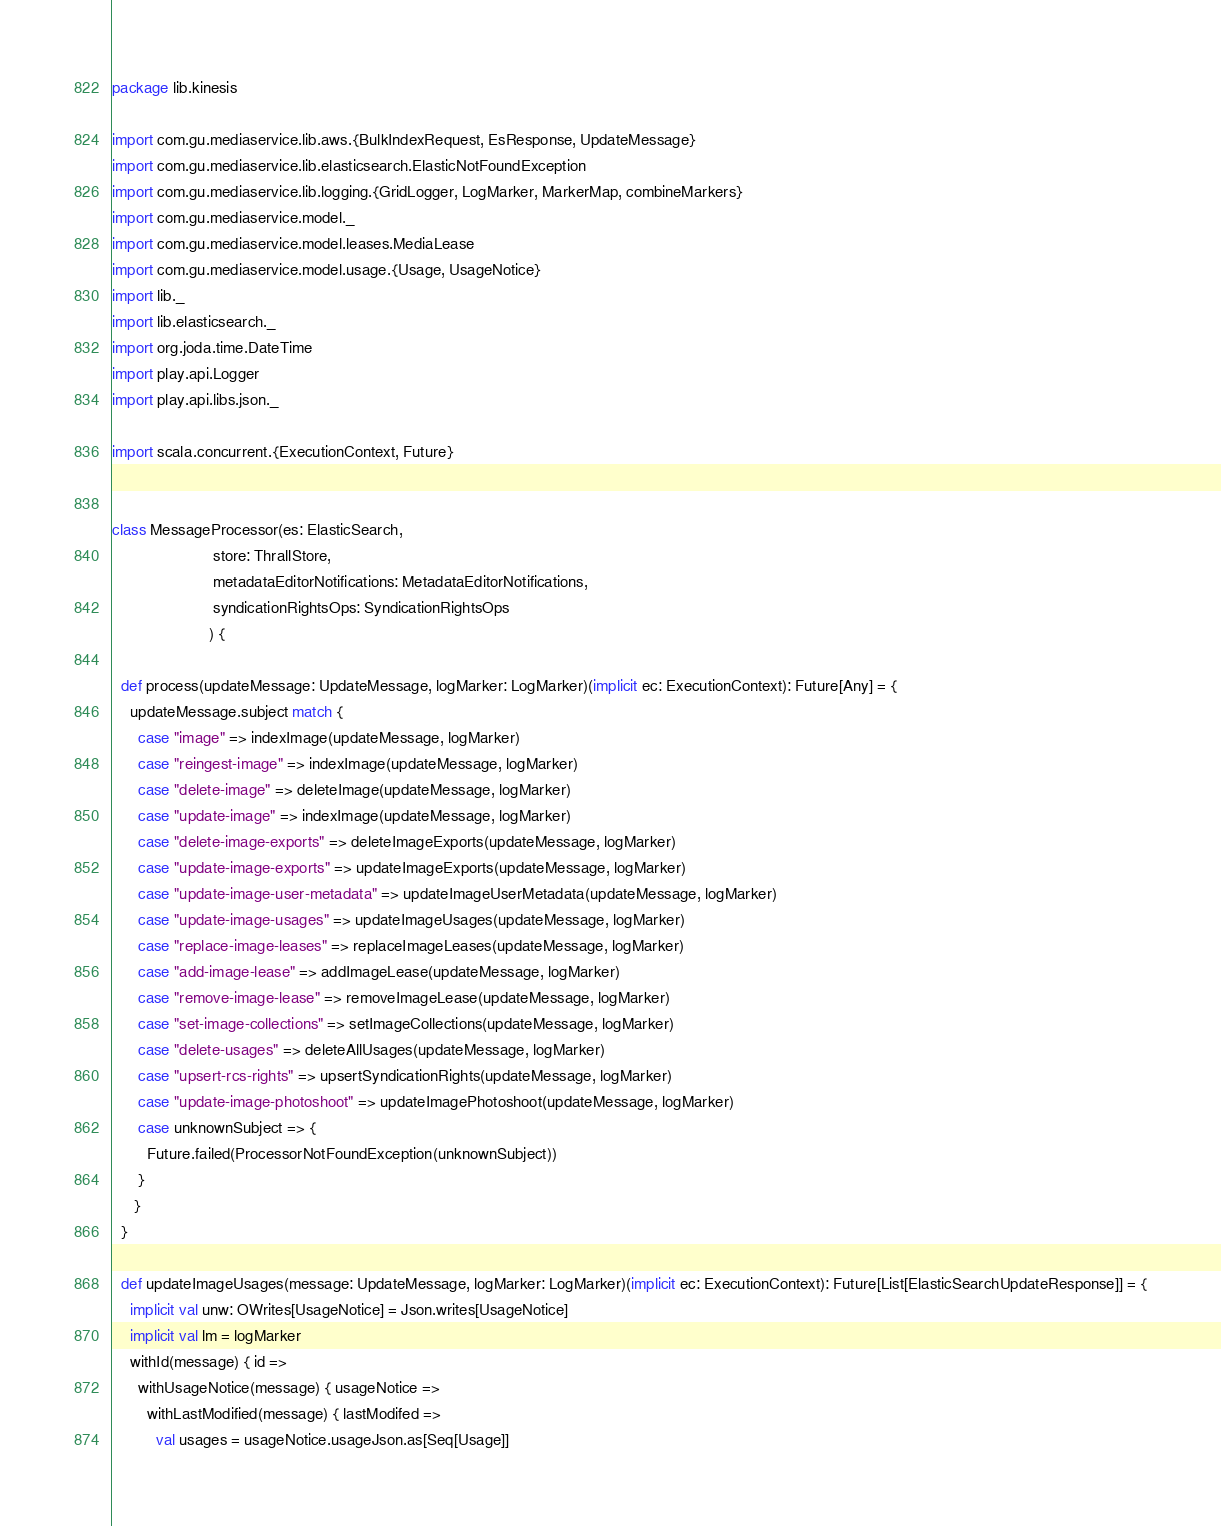Convert code to text. <code><loc_0><loc_0><loc_500><loc_500><_Scala_>package lib.kinesis

import com.gu.mediaservice.lib.aws.{BulkIndexRequest, EsResponse, UpdateMessage}
import com.gu.mediaservice.lib.elasticsearch.ElasticNotFoundException
import com.gu.mediaservice.lib.logging.{GridLogger, LogMarker, MarkerMap, combineMarkers}
import com.gu.mediaservice.model._
import com.gu.mediaservice.model.leases.MediaLease
import com.gu.mediaservice.model.usage.{Usage, UsageNotice}
import lib._
import lib.elasticsearch._
import org.joda.time.DateTime
import play.api.Logger
import play.api.libs.json._

import scala.concurrent.{ExecutionContext, Future}


class MessageProcessor(es: ElasticSearch,
                       store: ThrallStore,
                       metadataEditorNotifications: MetadataEditorNotifications,
                       syndicationRightsOps: SyndicationRightsOps
                      ) {

  def process(updateMessage: UpdateMessage, logMarker: LogMarker)(implicit ec: ExecutionContext): Future[Any] = {
    updateMessage.subject match {
      case "image" => indexImage(updateMessage, logMarker)
      case "reingest-image" => indexImage(updateMessage, logMarker)
      case "delete-image" => deleteImage(updateMessage, logMarker)
      case "update-image" => indexImage(updateMessage, logMarker)
      case "delete-image-exports" => deleteImageExports(updateMessage, logMarker)
      case "update-image-exports" => updateImageExports(updateMessage, logMarker)
      case "update-image-user-metadata" => updateImageUserMetadata(updateMessage, logMarker)
      case "update-image-usages" => updateImageUsages(updateMessage, logMarker)
      case "replace-image-leases" => replaceImageLeases(updateMessage, logMarker)
      case "add-image-lease" => addImageLease(updateMessage, logMarker)
      case "remove-image-lease" => removeImageLease(updateMessage, logMarker)
      case "set-image-collections" => setImageCollections(updateMessage, logMarker)
      case "delete-usages" => deleteAllUsages(updateMessage, logMarker)
      case "upsert-rcs-rights" => upsertSyndicationRights(updateMessage, logMarker)
      case "update-image-photoshoot" => updateImagePhotoshoot(updateMessage, logMarker)
      case unknownSubject => {
        Future.failed(ProcessorNotFoundException(unknownSubject))
      }
     }
  }

  def updateImageUsages(message: UpdateMessage, logMarker: LogMarker)(implicit ec: ExecutionContext): Future[List[ElasticSearchUpdateResponse]] = {
    implicit val unw: OWrites[UsageNotice] = Json.writes[UsageNotice]
    implicit val lm = logMarker
    withId(message) { id =>
      withUsageNotice(message) { usageNotice =>
        withLastModified(message) { lastModifed =>
          val usages = usageNotice.usageJson.as[Seq[Usage]]</code> 